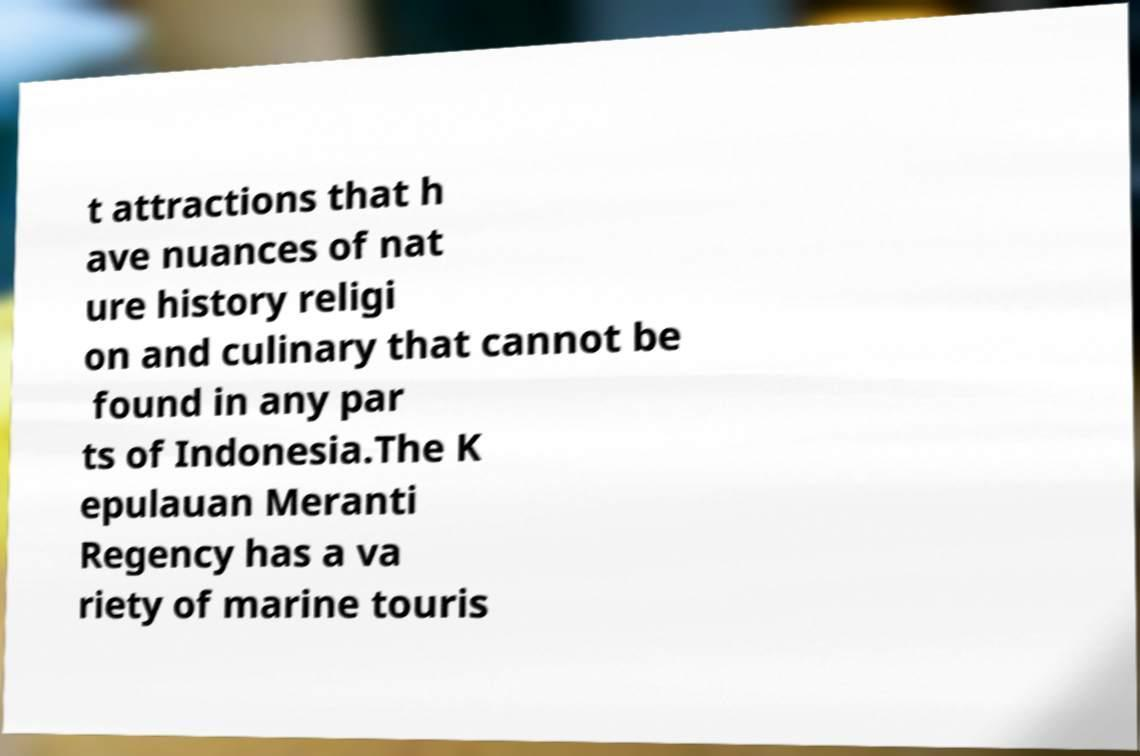Could you assist in decoding the text presented in this image and type it out clearly? t attractions that h ave nuances of nat ure history religi on and culinary that cannot be found in any par ts of Indonesia.The K epulauan Meranti Regency has a va riety of marine touris 